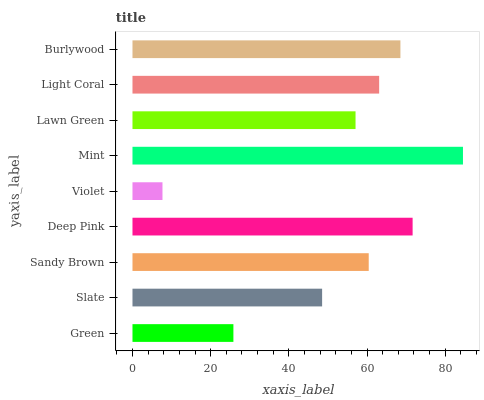Is Violet the minimum?
Answer yes or no. Yes. Is Mint the maximum?
Answer yes or no. Yes. Is Slate the minimum?
Answer yes or no. No. Is Slate the maximum?
Answer yes or no. No. Is Slate greater than Green?
Answer yes or no. Yes. Is Green less than Slate?
Answer yes or no. Yes. Is Green greater than Slate?
Answer yes or no. No. Is Slate less than Green?
Answer yes or no. No. Is Sandy Brown the high median?
Answer yes or no. Yes. Is Sandy Brown the low median?
Answer yes or no. Yes. Is Violet the high median?
Answer yes or no. No. Is Slate the low median?
Answer yes or no. No. 